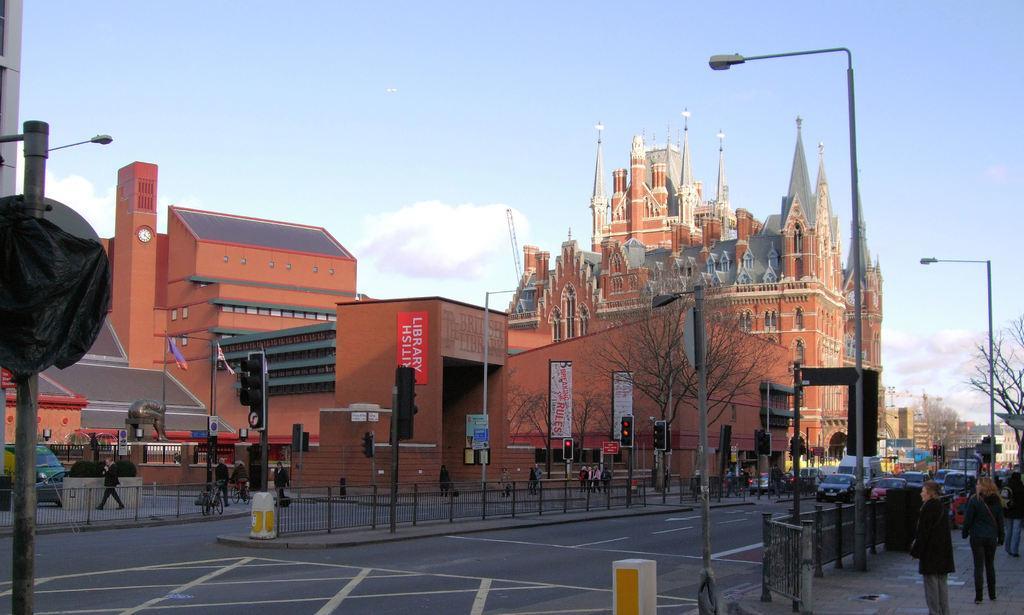Please provide a concise description of this image. In this image at the center there are cars on the road. At front there are buildings. In front of the buildings there are traffic signals. At the right side of the image there is a metal fencing. Behind that people were standing. There are trees at the right side of the image. At the background there is sky. 